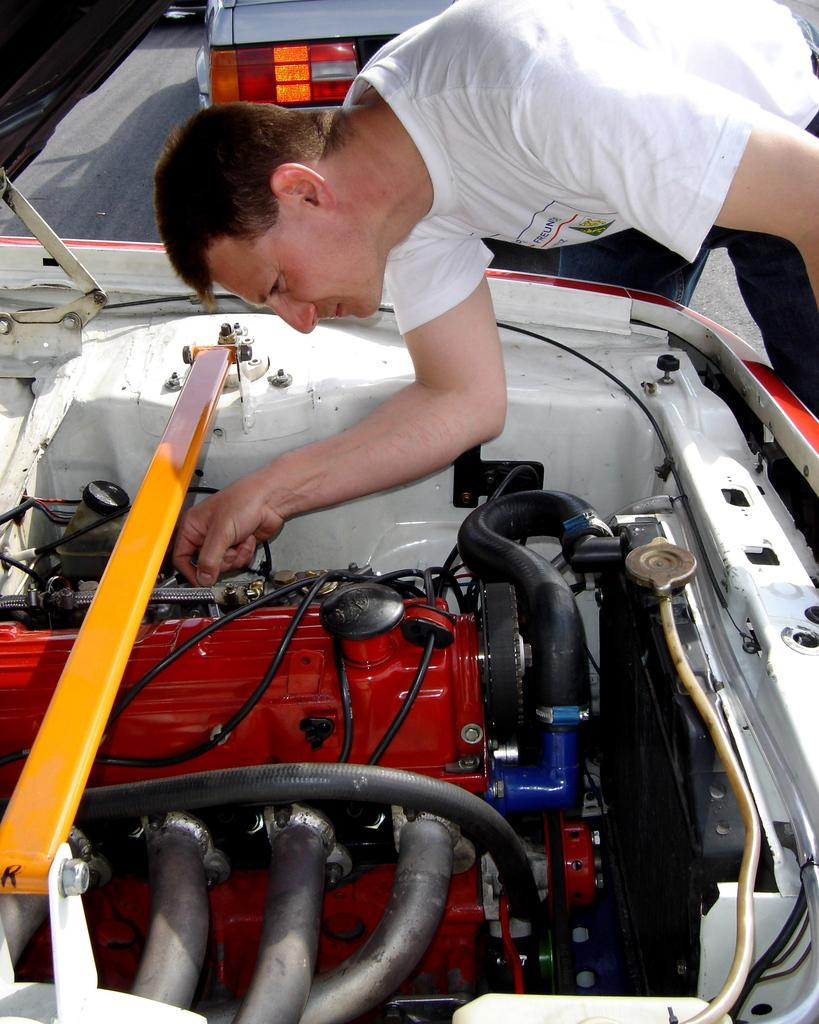What is the main subject in the foreground of the picture? There is a man in the foreground of the picture. What is the man wearing? The man is wearing a white T-shirt. What is the man doing in the picture? The man is standing in front of a car with an opened bonnet. What else can be seen in the background of the image? There is a vehicle visible in the background of the image. What is the health status of the man's nose in the image? There is no information about the man's nose or his health status in the image. 